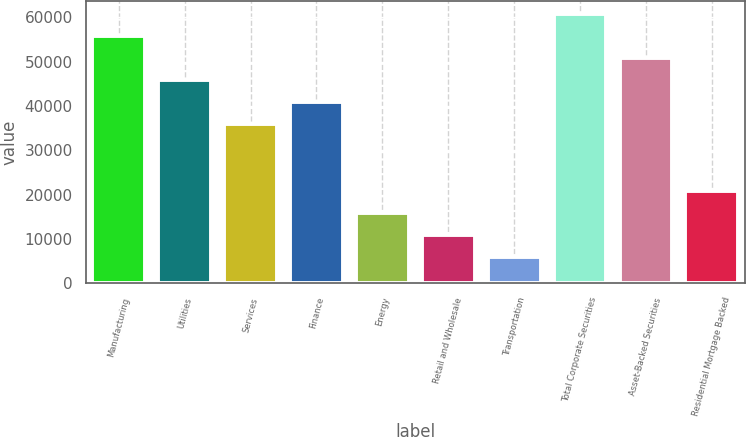Convert chart to OTSL. <chart><loc_0><loc_0><loc_500><loc_500><bar_chart><fcel>Manufacturing<fcel>Utilities<fcel>Services<fcel>Finance<fcel>Energy<fcel>Retail and Wholesale<fcel>Transportation<fcel>Total Corporate Securities<fcel>Asset-Backed Securities<fcel>Residential Mortgage Backed<nl><fcel>55750.5<fcel>45795.5<fcel>35840.5<fcel>40818<fcel>15930.5<fcel>10953<fcel>5975.5<fcel>60728<fcel>50773<fcel>20908<nl></chart> 